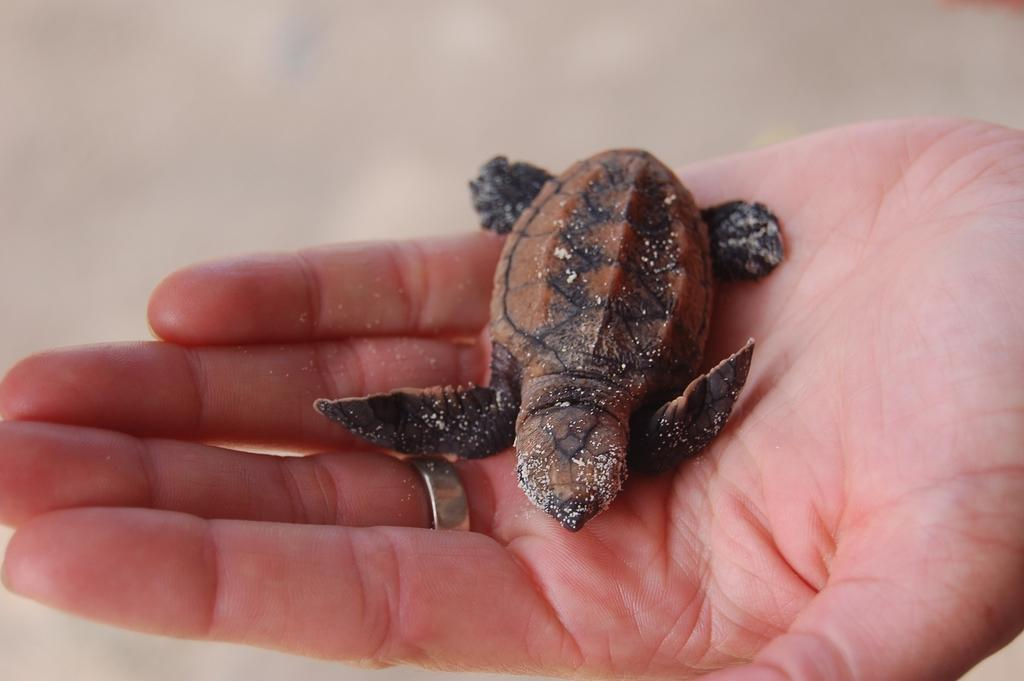What part of a person's body is visible in the image? There is a person's hand with a palm in the image. What animal is present in the image? There is a small turtle in the image. What is the color of the turtle? The turtle is brown in color. What type of accessory is on the person's finger? The person's finger has a ring on it. What type of liquid can be seen dripping from the turtle's shell in the image? There is no liquid dripping from the turtle's shell in the image; it is a brown turtle with no visible liquid. 